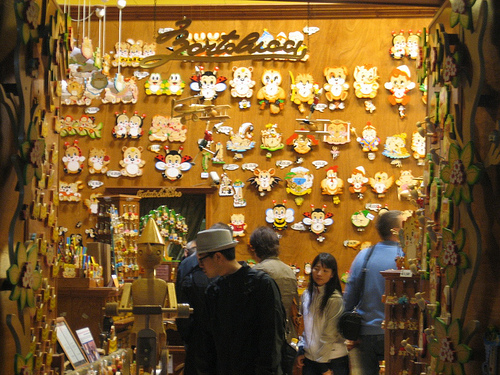<image>
Is the person in front of the woman? No. The person is not in front of the woman. The spatial positioning shows a different relationship between these objects. 